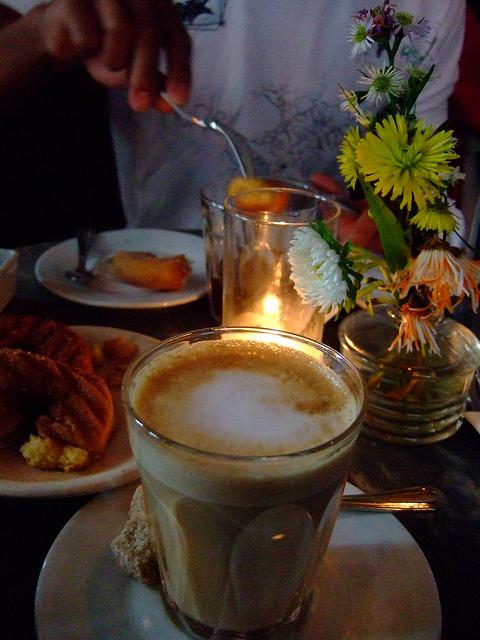Is the glass full?
Keep it brief. Yes. What is in the glass?
Quick response, please. Coffee. Is there a cup on the saucer closest to the camera?
Keep it brief. Yes. Are there flowers on the table?
Concise answer only. Yes. Is there anything hiding in the tasty drink?
Short answer required. No. 